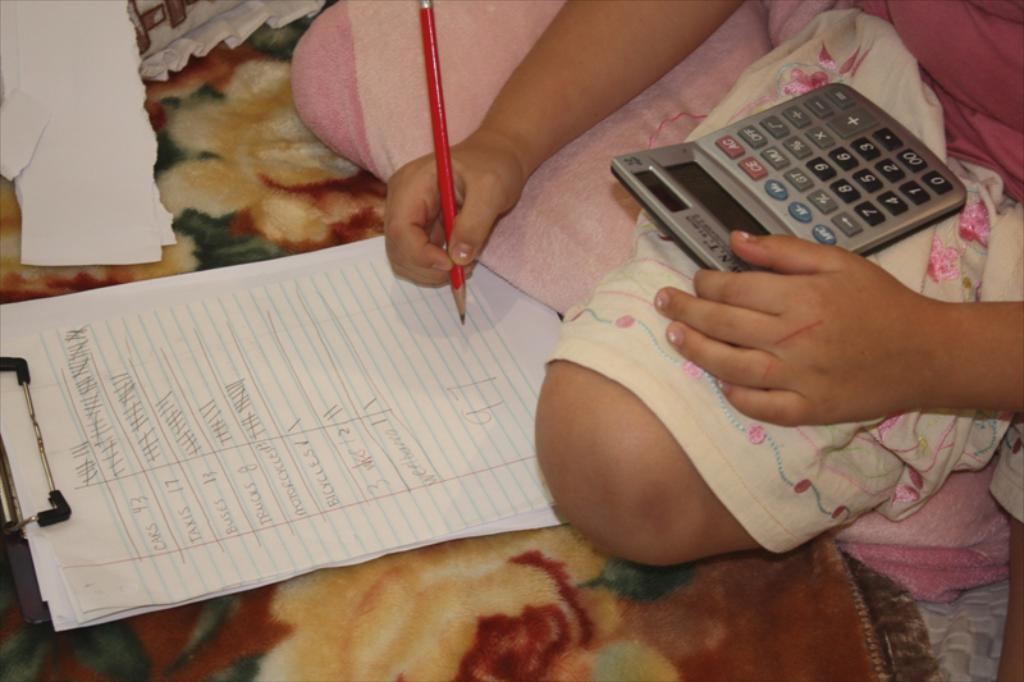What is the person on the bed doing? The person is sitting on the bed and holding a calculator and a pencil. What objects might the person be using for calculations or writing? The person is holding a calculator and a pencil, which could be used for calculations or writing. What is present on the bed that might be related to the person's activity? There are papers on the exam pad, which suggests the person might be working on something related to the calculator and pencil. Reasoning: Let's think step by step by step in order to produce the conversation. We start by identifying the main subject in the image, which is the person sitting on the bed. Then, we describe the objects the person is holding, which are a calculator and a pencil. Finally, we mention the presence of papers on the exam pad, which provides context for the person's activity. Each question is designed to elicit a specific detail about the image that is known from the provided facts. Absurd Question/Answer: What type of feather is the person using to write on the papers? There is no feather present in the image; the person is holding a pencil for writing. 